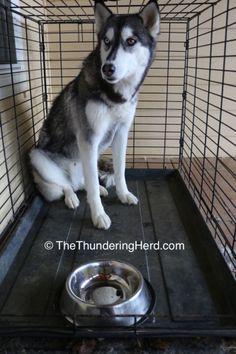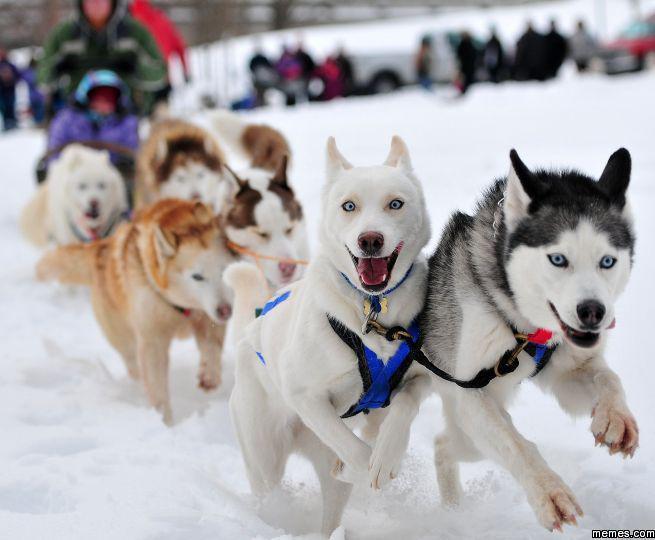The first image is the image on the left, the second image is the image on the right. Considering the images on both sides, is "A sled is being pulled over the snow by a team of dogs in one of the images." valid? Answer yes or no. Yes. The first image is the image on the left, the second image is the image on the right. Analyze the images presented: Is the assertion "One image has one dog and the other image has a pack of dogs." valid? Answer yes or no. Yes. 